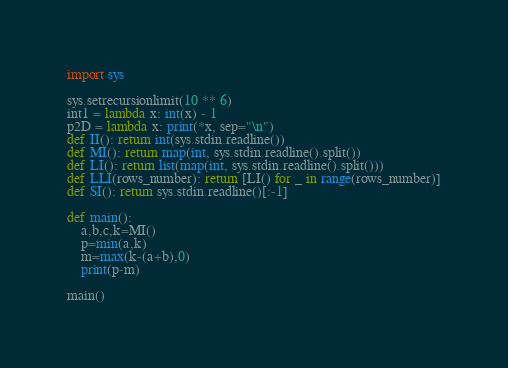<code> <loc_0><loc_0><loc_500><loc_500><_Python_>import sys

sys.setrecursionlimit(10 ** 6)
int1 = lambda x: int(x) - 1
p2D = lambda x: print(*x, sep="\n")
def II(): return int(sys.stdin.readline())
def MI(): return map(int, sys.stdin.readline().split())
def LI(): return list(map(int, sys.stdin.readline().split()))
def LLI(rows_number): return [LI() for _ in range(rows_number)]
def SI(): return sys.stdin.readline()[:-1]

def main():
    a,b,c,k=MI()
    p=min(a,k)
    m=max(k-(a+b),0)
    print(p-m)

main()</code> 